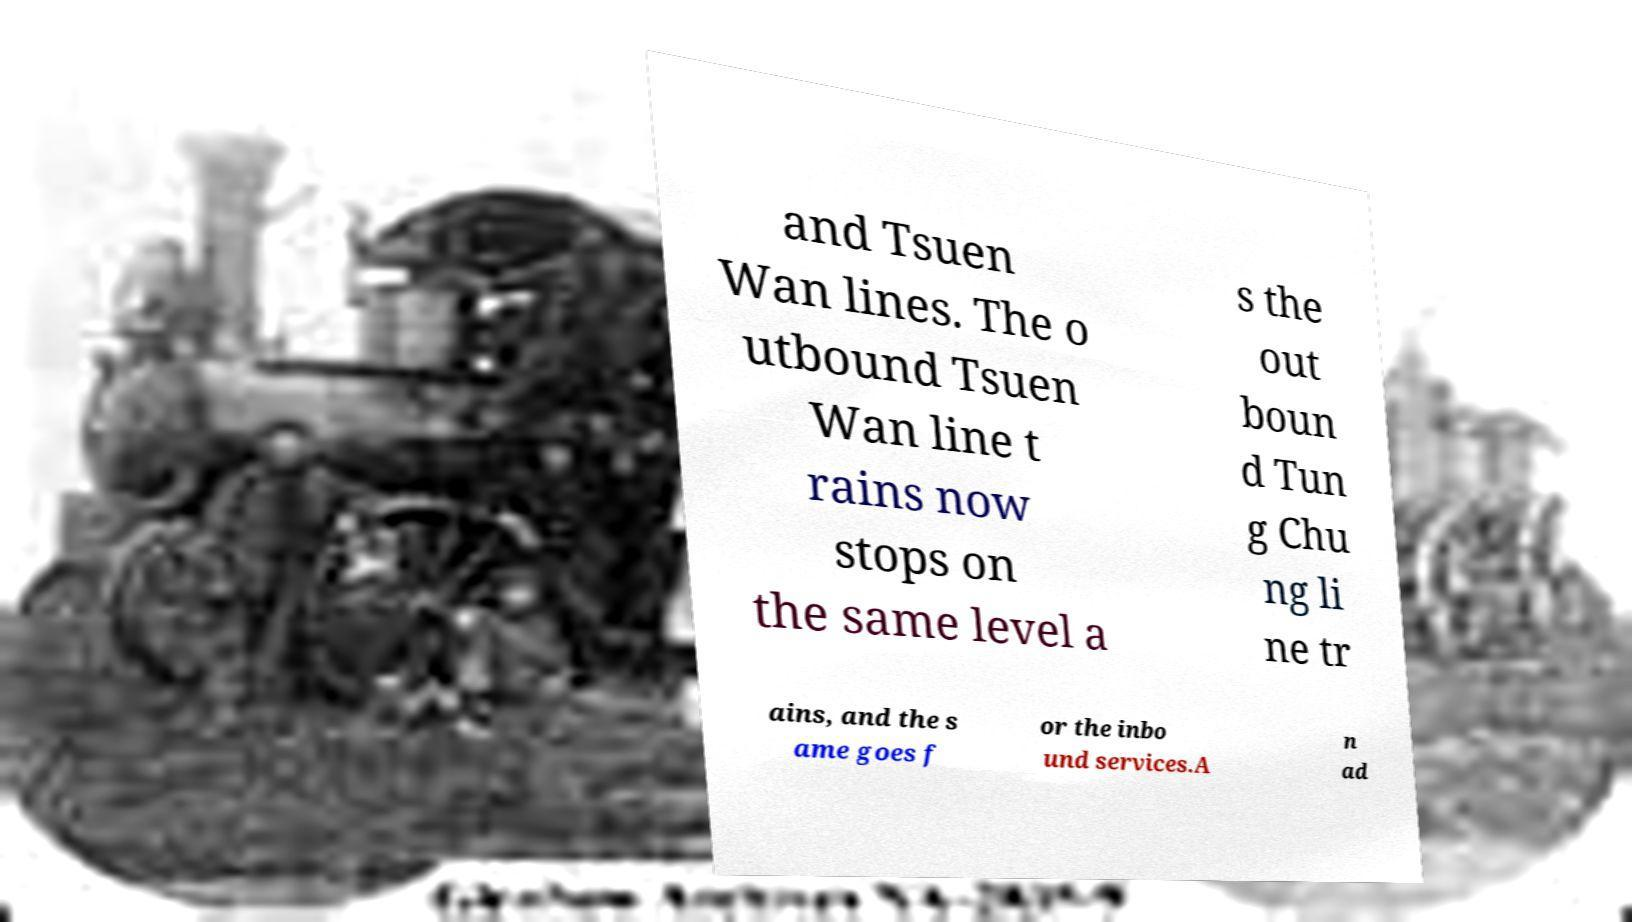Can you read and provide the text displayed in the image?This photo seems to have some interesting text. Can you extract and type it out for me? and Tsuen Wan lines. The o utbound Tsuen Wan line t rains now stops on the same level a s the out boun d Tun g Chu ng li ne tr ains, and the s ame goes f or the inbo und services.A n ad 